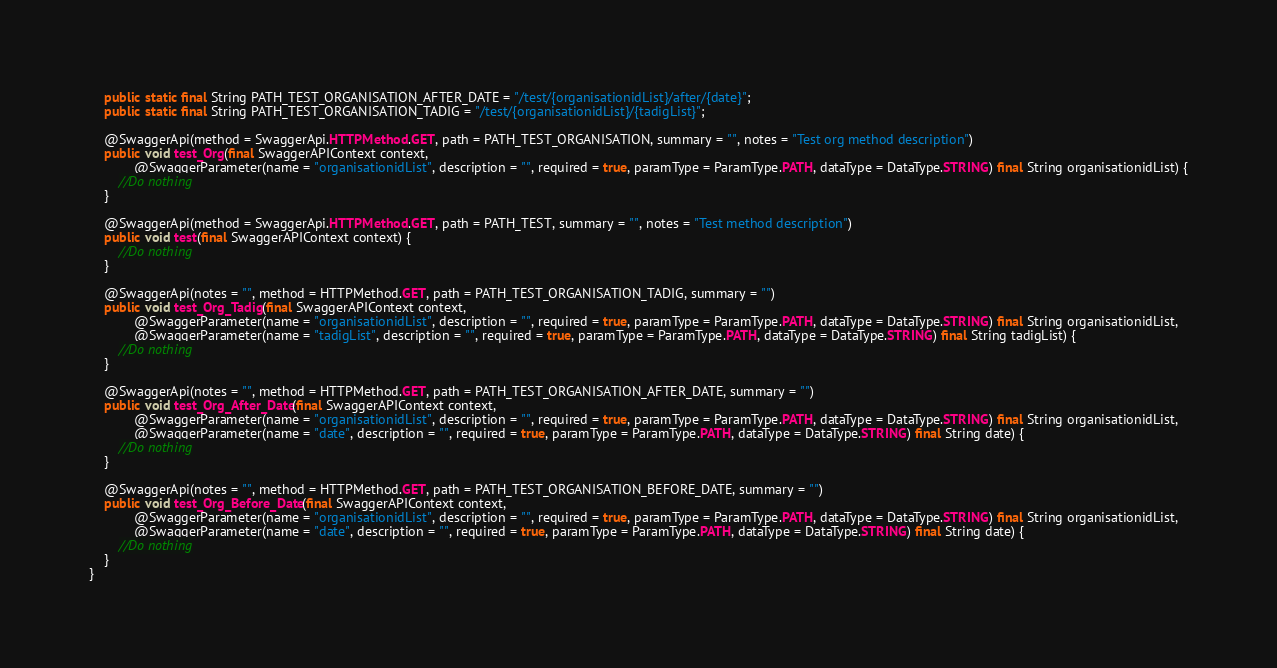<code> <loc_0><loc_0><loc_500><loc_500><_Java_>    public static final String PATH_TEST_ORGANISATION_AFTER_DATE = "/test/{organisationidList}/after/{date}";
    public static final String PATH_TEST_ORGANISATION_TADIG = "/test/{organisationidList}/{tadigList}";

    @SwaggerApi(method = SwaggerApi.HTTPMethod.GET, path = PATH_TEST_ORGANISATION, summary = "", notes = "Test org method description")
    public void test_Org(final SwaggerAPIContext context,
            @SwaggerParameter(name = "organisationidList", description = "", required = true, paramType = ParamType.PATH, dataType = DataType.STRING) final String organisationidList) {
        //Do nothing
    }

    @SwaggerApi(method = SwaggerApi.HTTPMethod.GET, path = PATH_TEST, summary = "", notes = "Test method description")
    public void test(final SwaggerAPIContext context) {
        //Do nothing
    }

    @SwaggerApi(notes = "", method = HTTPMethod.GET, path = PATH_TEST_ORGANISATION_TADIG, summary = "")
    public void test_Org_Tadig(final SwaggerAPIContext context,
            @SwaggerParameter(name = "organisationidList", description = "", required = true, paramType = ParamType.PATH, dataType = DataType.STRING) final String organisationidList,
            @SwaggerParameter(name = "tadigList", description = "", required = true, paramType = ParamType.PATH, dataType = DataType.STRING) final String tadigList) {
        //Do nothing
    }

    @SwaggerApi(notes = "", method = HTTPMethod.GET, path = PATH_TEST_ORGANISATION_AFTER_DATE, summary = "")
    public void test_Org_After_Date(final SwaggerAPIContext context,
            @SwaggerParameter(name = "organisationidList", description = "", required = true, paramType = ParamType.PATH, dataType = DataType.STRING) final String organisationidList,
            @SwaggerParameter(name = "date", description = "", required = true, paramType = ParamType.PATH, dataType = DataType.STRING) final String date) {
        //Do nothing
    }

    @SwaggerApi(notes = "", method = HTTPMethod.GET, path = PATH_TEST_ORGANISATION_BEFORE_DATE, summary = "")
    public void test_Org_Before_Date(final SwaggerAPIContext context,
            @SwaggerParameter(name = "organisationidList", description = "", required = true, paramType = ParamType.PATH, dataType = DataType.STRING) final String organisationidList,
            @SwaggerParameter(name = "date", description = "", required = true, paramType = ParamType.PATH, dataType = DataType.STRING) final String date) {
        //Do nothing
    }
}</code> 